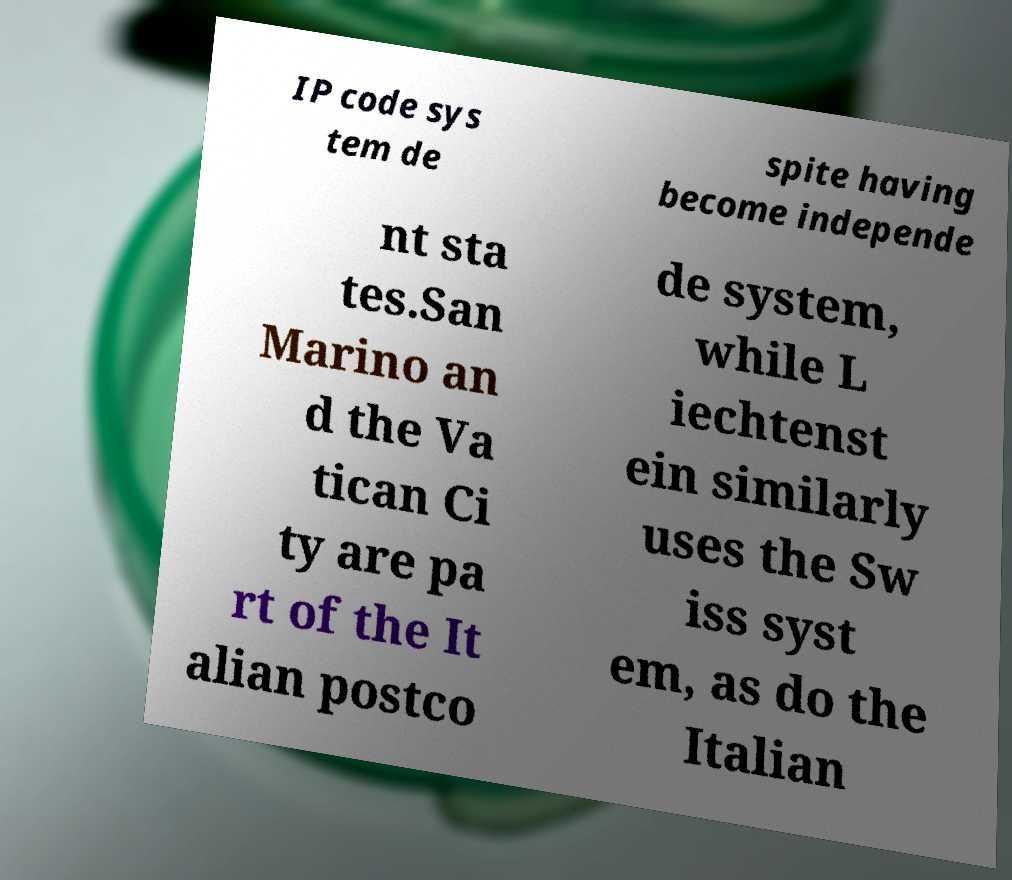Can you read and provide the text displayed in the image?This photo seems to have some interesting text. Can you extract and type it out for me? IP code sys tem de spite having become independe nt sta tes.San Marino an d the Va tican Ci ty are pa rt of the It alian postco de system, while L iechtenst ein similarly uses the Sw iss syst em, as do the Italian 